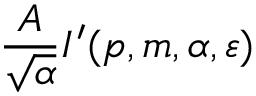Convert formula to latex. <formula><loc_0><loc_0><loc_500><loc_500>\frac { A } { \sqrt { \alpha } } I ^ { \prime } ( p , m , \alpha , \varepsilon )</formula> 